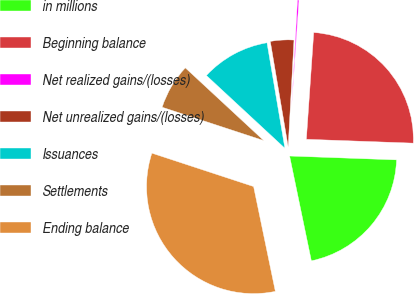<chart> <loc_0><loc_0><loc_500><loc_500><pie_chart><fcel>in millions<fcel>Beginning balance<fcel>Net realized gains/(losses)<fcel>Net unrealized gains/(losses)<fcel>Issuances<fcel>Settlements<fcel>Ending balance<nl><fcel>21.17%<fcel>24.48%<fcel>0.23%<fcel>3.54%<fcel>10.43%<fcel>6.85%<fcel>33.31%<nl></chart> 